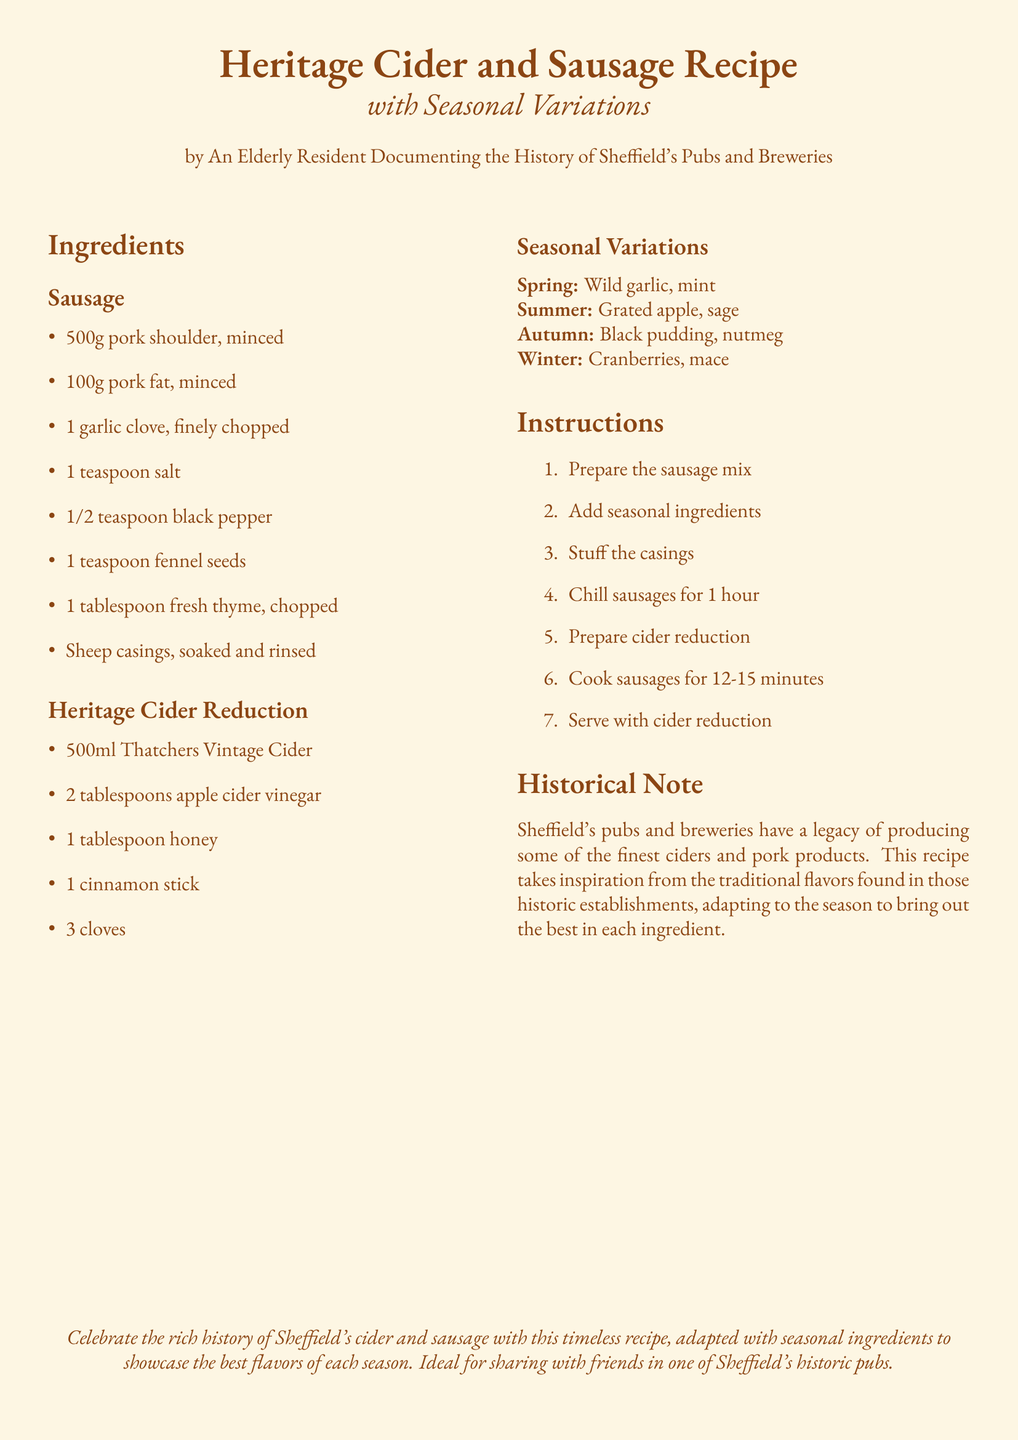What type of recipe is this? The document is about a recipe that combines cider and sausages, focusing on heritage cooking with seasonal variations.
Answer: Heritage Cider and Sausage Recipe How many grams of pork shoulder are required? The recipe lists the required amount of pork shoulder in grams under the sausage ingredients section.
Answer: 500g What should be added for the Winter variation? The seasonal variations section specifies which ingredients are added during Winter.
Answer: Cranberries, mace How long should the sausages be cooked? The cooking time for the sausages is outlined in the instructions.
Answer: 12-15 minutes What is the first step in the recipe instructions? The instructions list the steps in order, and the first step is clearly stated.
Answer: Prepare the sausage mix What is included in the Heritage Cider Reduction? The cider reduction ingredients list includes several specific components mentioned in the document.
Answer: 500ml Thatchers Vintage Cider, 2 tablespoons apple cider vinegar, 1 tablespoon honey, 1 cinnamon stick, 3 cloves Which herb is suggested for the Spring variation? The seasonal variations section specifically mentions which herb to use in Spring.
Answer: Wild garlic Who authored the recipe? The author of the recipe is mentioned in the header of the document.
Answer: An Elderly Resident Documenting the History of Sheffield's Pubs and Breweries 